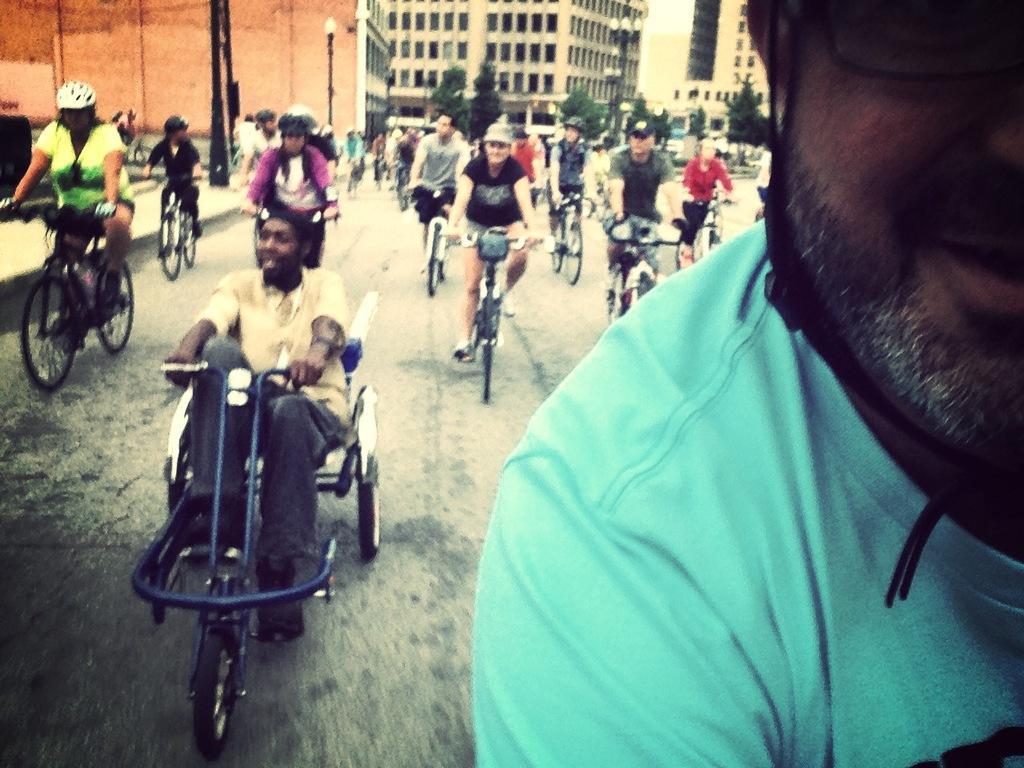How would you summarize this image in a sentence or two? In this picture we can see group of people riding bicycles on the road and they all wore helmets and in the background we can see building, pole, light, trees. 